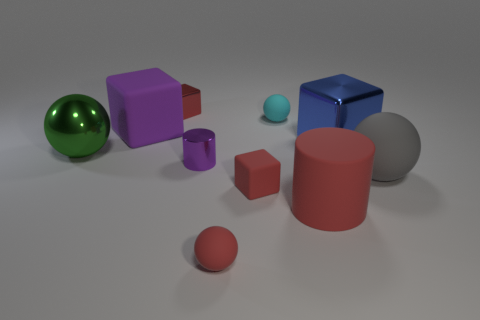Subtract all large blue metal blocks. How many blocks are left? 3 Subtract all spheres. How many objects are left? 6 Subtract 1 cylinders. How many cylinders are left? 1 Subtract all green spheres. Subtract all brown cylinders. How many spheres are left? 3 Subtract all brown cylinders. How many green balls are left? 1 Subtract all cyan matte spheres. Subtract all red rubber balls. How many objects are left? 8 Add 6 red blocks. How many red blocks are left? 8 Add 5 red metal objects. How many red metal objects exist? 6 Subtract all green spheres. How many spheres are left? 3 Subtract 0 green blocks. How many objects are left? 10 